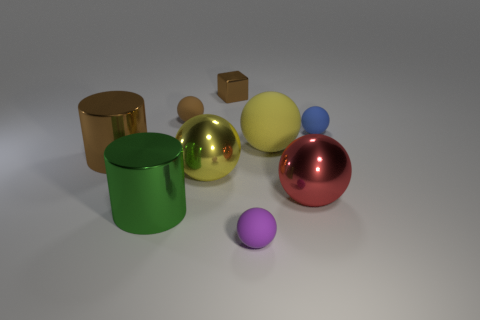What is the shape of the large green metal object?
Provide a succinct answer. Cylinder. There is a ball in front of the red shiny ball; what is its material?
Provide a succinct answer. Rubber. How many matte objects are either blue objects or yellow spheres?
Give a very brief answer. 2. The tiny rubber thing that is in front of the tiny object right of the tiny purple object is what color?
Ensure brevity in your answer.  Purple. Do the purple ball and the yellow sphere behind the large brown cylinder have the same material?
Your response must be concise. Yes. What color is the tiny thing in front of the yellow thing left of the small sphere in front of the small blue sphere?
Offer a terse response. Purple. Is there anything else that has the same shape as the small brown shiny object?
Ensure brevity in your answer.  No. Are there more red shiny objects than blue shiny cylinders?
Offer a terse response. Yes. What number of small things are in front of the small brown metal cube and to the right of the brown ball?
Give a very brief answer. 2. There is a large yellow ball that is right of the tiny brown metallic thing; how many brown cubes are in front of it?
Provide a succinct answer. 0. 